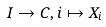Convert formula to latex. <formula><loc_0><loc_0><loc_500><loc_500>I \rightarrow C , i \mapsto X _ { i }</formula> 